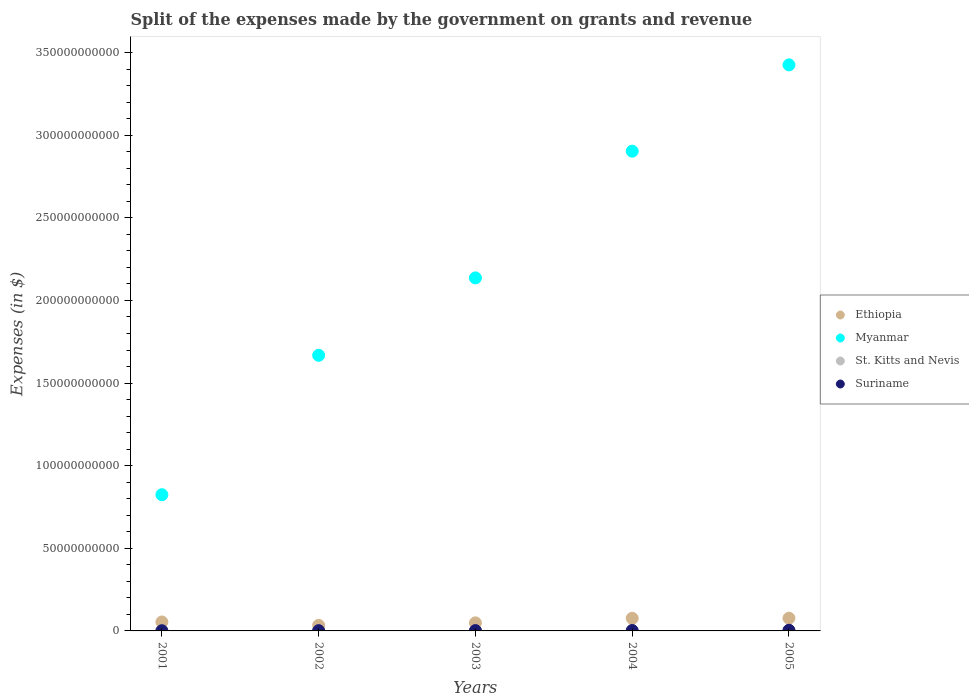How many different coloured dotlines are there?
Your response must be concise. 4. Is the number of dotlines equal to the number of legend labels?
Ensure brevity in your answer.  Yes. What is the expenses made by the government on grants and revenue in Ethiopia in 2005?
Keep it short and to the point. 7.71e+09. Across all years, what is the maximum expenses made by the government on grants and revenue in Myanmar?
Ensure brevity in your answer.  3.43e+11. Across all years, what is the minimum expenses made by the government on grants and revenue in Suriname?
Provide a short and direct response. 1.17e+08. In which year was the expenses made by the government on grants and revenue in Suriname maximum?
Offer a very short reply. 2005. In which year was the expenses made by the government on grants and revenue in Myanmar minimum?
Offer a terse response. 2001. What is the total expenses made by the government on grants and revenue in Suriname in the graph?
Your answer should be compact. 1.14e+09. What is the difference between the expenses made by the government on grants and revenue in Ethiopia in 2001 and that in 2002?
Keep it short and to the point. 2.05e+09. What is the difference between the expenses made by the government on grants and revenue in St. Kitts and Nevis in 2004 and the expenses made by the government on grants and revenue in Suriname in 2002?
Make the answer very short. -7.63e+07. What is the average expenses made by the government on grants and revenue in St. Kitts and Nevis per year?
Offer a very short reply. 1.03e+08. In the year 2005, what is the difference between the expenses made by the government on grants and revenue in St. Kitts and Nevis and expenses made by the government on grants and revenue in Ethiopia?
Offer a terse response. -7.59e+09. In how many years, is the expenses made by the government on grants and revenue in Myanmar greater than 70000000000 $?
Your response must be concise. 5. What is the ratio of the expenses made by the government on grants and revenue in Ethiopia in 2004 to that in 2005?
Give a very brief answer. 0.99. Is the difference between the expenses made by the government on grants and revenue in St. Kitts and Nevis in 2001 and 2005 greater than the difference between the expenses made by the government on grants and revenue in Ethiopia in 2001 and 2005?
Make the answer very short. Yes. What is the difference between the highest and the second highest expenses made by the government on grants and revenue in Suriname?
Ensure brevity in your answer.  1.41e+08. What is the difference between the highest and the lowest expenses made by the government on grants and revenue in Suriname?
Make the answer very short. 2.78e+08. In how many years, is the expenses made by the government on grants and revenue in Ethiopia greater than the average expenses made by the government on grants and revenue in Ethiopia taken over all years?
Give a very brief answer. 2. Is it the case that in every year, the sum of the expenses made by the government on grants and revenue in Suriname and expenses made by the government on grants and revenue in St. Kitts and Nevis  is greater than the sum of expenses made by the government on grants and revenue in Myanmar and expenses made by the government on grants and revenue in Ethiopia?
Your answer should be very brief. No. Is it the case that in every year, the sum of the expenses made by the government on grants and revenue in Suriname and expenses made by the government on grants and revenue in Ethiopia  is greater than the expenses made by the government on grants and revenue in St. Kitts and Nevis?
Your answer should be very brief. Yes. Is the expenses made by the government on grants and revenue in St. Kitts and Nevis strictly greater than the expenses made by the government on grants and revenue in Ethiopia over the years?
Offer a terse response. No. What is the difference between two consecutive major ticks on the Y-axis?
Ensure brevity in your answer.  5.00e+1. Does the graph contain any zero values?
Your answer should be very brief. No. Does the graph contain grids?
Your answer should be very brief. No. Where does the legend appear in the graph?
Provide a succinct answer. Center right. What is the title of the graph?
Your answer should be compact. Split of the expenses made by the government on grants and revenue. What is the label or title of the X-axis?
Provide a short and direct response. Years. What is the label or title of the Y-axis?
Give a very brief answer. Expenses (in $). What is the Expenses (in $) of Ethiopia in 2001?
Your answer should be compact. 5.41e+09. What is the Expenses (in $) of Myanmar in 2001?
Offer a very short reply. 8.24e+1. What is the Expenses (in $) of St. Kitts and Nevis in 2001?
Your answer should be compact. 9.49e+07. What is the Expenses (in $) of Suriname in 2001?
Make the answer very short. 1.17e+08. What is the Expenses (in $) of Ethiopia in 2002?
Offer a very short reply. 3.36e+09. What is the Expenses (in $) of Myanmar in 2002?
Keep it short and to the point. 1.67e+11. What is the Expenses (in $) in St. Kitts and Nevis in 2002?
Provide a short and direct response. 1.15e+08. What is the Expenses (in $) of Suriname in 2002?
Provide a short and direct response. 1.64e+08. What is the Expenses (in $) of Ethiopia in 2003?
Make the answer very short. 4.88e+09. What is the Expenses (in $) of Myanmar in 2003?
Provide a short and direct response. 2.14e+11. What is the Expenses (in $) in St. Kitts and Nevis in 2003?
Your answer should be compact. 9.36e+07. What is the Expenses (in $) of Suriname in 2003?
Provide a succinct answer. 2.09e+08. What is the Expenses (in $) in Ethiopia in 2004?
Your answer should be very brief. 7.63e+09. What is the Expenses (in $) in Myanmar in 2004?
Offer a very short reply. 2.90e+11. What is the Expenses (in $) in St. Kitts and Nevis in 2004?
Offer a very short reply. 8.76e+07. What is the Expenses (in $) of Suriname in 2004?
Provide a short and direct response. 2.53e+08. What is the Expenses (in $) of Ethiopia in 2005?
Make the answer very short. 7.71e+09. What is the Expenses (in $) in Myanmar in 2005?
Give a very brief answer. 3.43e+11. What is the Expenses (in $) in St. Kitts and Nevis in 2005?
Make the answer very short. 1.22e+08. What is the Expenses (in $) of Suriname in 2005?
Provide a short and direct response. 3.94e+08. Across all years, what is the maximum Expenses (in $) in Ethiopia?
Offer a very short reply. 7.71e+09. Across all years, what is the maximum Expenses (in $) of Myanmar?
Offer a terse response. 3.43e+11. Across all years, what is the maximum Expenses (in $) in St. Kitts and Nevis?
Offer a very short reply. 1.22e+08. Across all years, what is the maximum Expenses (in $) in Suriname?
Offer a very short reply. 3.94e+08. Across all years, what is the minimum Expenses (in $) in Ethiopia?
Your response must be concise. 3.36e+09. Across all years, what is the minimum Expenses (in $) of Myanmar?
Make the answer very short. 8.24e+1. Across all years, what is the minimum Expenses (in $) of St. Kitts and Nevis?
Your answer should be very brief. 8.76e+07. Across all years, what is the minimum Expenses (in $) in Suriname?
Provide a succinct answer. 1.17e+08. What is the total Expenses (in $) of Ethiopia in the graph?
Your response must be concise. 2.90e+1. What is the total Expenses (in $) in Myanmar in the graph?
Your response must be concise. 1.10e+12. What is the total Expenses (in $) of St. Kitts and Nevis in the graph?
Make the answer very short. 5.13e+08. What is the total Expenses (in $) of Suriname in the graph?
Your answer should be compact. 1.14e+09. What is the difference between the Expenses (in $) of Ethiopia in 2001 and that in 2002?
Provide a succinct answer. 2.05e+09. What is the difference between the Expenses (in $) of Myanmar in 2001 and that in 2002?
Offer a very short reply. -8.44e+1. What is the difference between the Expenses (in $) of St. Kitts and Nevis in 2001 and that in 2002?
Offer a terse response. -2.04e+07. What is the difference between the Expenses (in $) in Suriname in 2001 and that in 2002?
Provide a short and direct response. -4.73e+07. What is the difference between the Expenses (in $) of Ethiopia in 2001 and that in 2003?
Give a very brief answer. 5.34e+08. What is the difference between the Expenses (in $) of Myanmar in 2001 and that in 2003?
Your answer should be very brief. -1.31e+11. What is the difference between the Expenses (in $) in St. Kitts and Nevis in 2001 and that in 2003?
Provide a succinct answer. 1.30e+06. What is the difference between the Expenses (in $) in Suriname in 2001 and that in 2003?
Ensure brevity in your answer.  -9.21e+07. What is the difference between the Expenses (in $) of Ethiopia in 2001 and that in 2004?
Offer a terse response. -2.22e+09. What is the difference between the Expenses (in $) of Myanmar in 2001 and that in 2004?
Give a very brief answer. -2.08e+11. What is the difference between the Expenses (in $) of St. Kitts and Nevis in 2001 and that in 2004?
Your response must be concise. 7.30e+06. What is the difference between the Expenses (in $) of Suriname in 2001 and that in 2004?
Make the answer very short. -1.37e+08. What is the difference between the Expenses (in $) in Ethiopia in 2001 and that in 2005?
Offer a very short reply. -2.30e+09. What is the difference between the Expenses (in $) in Myanmar in 2001 and that in 2005?
Give a very brief answer. -2.60e+11. What is the difference between the Expenses (in $) of St. Kitts and Nevis in 2001 and that in 2005?
Your answer should be very brief. -2.69e+07. What is the difference between the Expenses (in $) in Suriname in 2001 and that in 2005?
Provide a succinct answer. -2.78e+08. What is the difference between the Expenses (in $) of Ethiopia in 2002 and that in 2003?
Offer a terse response. -1.51e+09. What is the difference between the Expenses (in $) of Myanmar in 2002 and that in 2003?
Your answer should be compact. -4.68e+1. What is the difference between the Expenses (in $) in St. Kitts and Nevis in 2002 and that in 2003?
Offer a very short reply. 2.17e+07. What is the difference between the Expenses (in $) in Suriname in 2002 and that in 2003?
Keep it short and to the point. -4.48e+07. What is the difference between the Expenses (in $) in Ethiopia in 2002 and that in 2004?
Offer a very short reply. -4.27e+09. What is the difference between the Expenses (in $) of Myanmar in 2002 and that in 2004?
Your response must be concise. -1.24e+11. What is the difference between the Expenses (in $) in St. Kitts and Nevis in 2002 and that in 2004?
Provide a short and direct response. 2.77e+07. What is the difference between the Expenses (in $) in Suriname in 2002 and that in 2004?
Provide a short and direct response. -8.93e+07. What is the difference between the Expenses (in $) in Ethiopia in 2002 and that in 2005?
Make the answer very short. -4.35e+09. What is the difference between the Expenses (in $) in Myanmar in 2002 and that in 2005?
Ensure brevity in your answer.  -1.76e+11. What is the difference between the Expenses (in $) in St. Kitts and Nevis in 2002 and that in 2005?
Offer a terse response. -6.50e+06. What is the difference between the Expenses (in $) in Suriname in 2002 and that in 2005?
Your answer should be very brief. -2.30e+08. What is the difference between the Expenses (in $) in Ethiopia in 2003 and that in 2004?
Your response must be concise. -2.76e+09. What is the difference between the Expenses (in $) of Myanmar in 2003 and that in 2004?
Provide a short and direct response. -7.67e+1. What is the difference between the Expenses (in $) of Suriname in 2003 and that in 2004?
Provide a short and direct response. -4.45e+07. What is the difference between the Expenses (in $) of Ethiopia in 2003 and that in 2005?
Give a very brief answer. -2.84e+09. What is the difference between the Expenses (in $) in Myanmar in 2003 and that in 2005?
Ensure brevity in your answer.  -1.29e+11. What is the difference between the Expenses (in $) of St. Kitts and Nevis in 2003 and that in 2005?
Your answer should be compact. -2.82e+07. What is the difference between the Expenses (in $) of Suriname in 2003 and that in 2005?
Provide a short and direct response. -1.86e+08. What is the difference between the Expenses (in $) in Ethiopia in 2004 and that in 2005?
Provide a short and direct response. -7.96e+07. What is the difference between the Expenses (in $) of Myanmar in 2004 and that in 2005?
Your response must be concise. -5.22e+1. What is the difference between the Expenses (in $) in St. Kitts and Nevis in 2004 and that in 2005?
Your response must be concise. -3.42e+07. What is the difference between the Expenses (in $) of Suriname in 2004 and that in 2005?
Make the answer very short. -1.41e+08. What is the difference between the Expenses (in $) in Ethiopia in 2001 and the Expenses (in $) in Myanmar in 2002?
Make the answer very short. -1.61e+11. What is the difference between the Expenses (in $) of Ethiopia in 2001 and the Expenses (in $) of St. Kitts and Nevis in 2002?
Give a very brief answer. 5.30e+09. What is the difference between the Expenses (in $) in Ethiopia in 2001 and the Expenses (in $) in Suriname in 2002?
Ensure brevity in your answer.  5.25e+09. What is the difference between the Expenses (in $) in Myanmar in 2001 and the Expenses (in $) in St. Kitts and Nevis in 2002?
Your answer should be very brief. 8.23e+1. What is the difference between the Expenses (in $) of Myanmar in 2001 and the Expenses (in $) of Suriname in 2002?
Offer a terse response. 8.23e+1. What is the difference between the Expenses (in $) in St. Kitts and Nevis in 2001 and the Expenses (in $) in Suriname in 2002?
Your response must be concise. -6.90e+07. What is the difference between the Expenses (in $) in Ethiopia in 2001 and the Expenses (in $) in Myanmar in 2003?
Keep it short and to the point. -2.08e+11. What is the difference between the Expenses (in $) in Ethiopia in 2001 and the Expenses (in $) in St. Kitts and Nevis in 2003?
Ensure brevity in your answer.  5.32e+09. What is the difference between the Expenses (in $) of Ethiopia in 2001 and the Expenses (in $) of Suriname in 2003?
Provide a succinct answer. 5.20e+09. What is the difference between the Expenses (in $) in Myanmar in 2001 and the Expenses (in $) in St. Kitts and Nevis in 2003?
Your answer should be compact. 8.23e+1. What is the difference between the Expenses (in $) of Myanmar in 2001 and the Expenses (in $) of Suriname in 2003?
Provide a succinct answer. 8.22e+1. What is the difference between the Expenses (in $) in St. Kitts and Nevis in 2001 and the Expenses (in $) in Suriname in 2003?
Ensure brevity in your answer.  -1.14e+08. What is the difference between the Expenses (in $) of Ethiopia in 2001 and the Expenses (in $) of Myanmar in 2004?
Provide a succinct answer. -2.85e+11. What is the difference between the Expenses (in $) of Ethiopia in 2001 and the Expenses (in $) of St. Kitts and Nevis in 2004?
Your response must be concise. 5.32e+09. What is the difference between the Expenses (in $) of Ethiopia in 2001 and the Expenses (in $) of Suriname in 2004?
Make the answer very short. 5.16e+09. What is the difference between the Expenses (in $) of Myanmar in 2001 and the Expenses (in $) of St. Kitts and Nevis in 2004?
Your answer should be very brief. 8.24e+1. What is the difference between the Expenses (in $) in Myanmar in 2001 and the Expenses (in $) in Suriname in 2004?
Your answer should be compact. 8.22e+1. What is the difference between the Expenses (in $) in St. Kitts and Nevis in 2001 and the Expenses (in $) in Suriname in 2004?
Give a very brief answer. -1.58e+08. What is the difference between the Expenses (in $) of Ethiopia in 2001 and the Expenses (in $) of Myanmar in 2005?
Give a very brief answer. -3.37e+11. What is the difference between the Expenses (in $) of Ethiopia in 2001 and the Expenses (in $) of St. Kitts and Nevis in 2005?
Keep it short and to the point. 5.29e+09. What is the difference between the Expenses (in $) in Ethiopia in 2001 and the Expenses (in $) in Suriname in 2005?
Your answer should be compact. 5.02e+09. What is the difference between the Expenses (in $) of Myanmar in 2001 and the Expenses (in $) of St. Kitts and Nevis in 2005?
Give a very brief answer. 8.23e+1. What is the difference between the Expenses (in $) in Myanmar in 2001 and the Expenses (in $) in Suriname in 2005?
Your answer should be compact. 8.20e+1. What is the difference between the Expenses (in $) in St. Kitts and Nevis in 2001 and the Expenses (in $) in Suriname in 2005?
Your answer should be compact. -2.99e+08. What is the difference between the Expenses (in $) in Ethiopia in 2002 and the Expenses (in $) in Myanmar in 2003?
Make the answer very short. -2.10e+11. What is the difference between the Expenses (in $) in Ethiopia in 2002 and the Expenses (in $) in St. Kitts and Nevis in 2003?
Provide a short and direct response. 3.27e+09. What is the difference between the Expenses (in $) of Ethiopia in 2002 and the Expenses (in $) of Suriname in 2003?
Your answer should be compact. 3.15e+09. What is the difference between the Expenses (in $) of Myanmar in 2002 and the Expenses (in $) of St. Kitts and Nevis in 2003?
Give a very brief answer. 1.67e+11. What is the difference between the Expenses (in $) of Myanmar in 2002 and the Expenses (in $) of Suriname in 2003?
Give a very brief answer. 1.67e+11. What is the difference between the Expenses (in $) of St. Kitts and Nevis in 2002 and the Expenses (in $) of Suriname in 2003?
Keep it short and to the point. -9.35e+07. What is the difference between the Expenses (in $) of Ethiopia in 2002 and the Expenses (in $) of Myanmar in 2004?
Your answer should be compact. -2.87e+11. What is the difference between the Expenses (in $) in Ethiopia in 2002 and the Expenses (in $) in St. Kitts and Nevis in 2004?
Offer a terse response. 3.27e+09. What is the difference between the Expenses (in $) in Ethiopia in 2002 and the Expenses (in $) in Suriname in 2004?
Your answer should be compact. 3.11e+09. What is the difference between the Expenses (in $) in Myanmar in 2002 and the Expenses (in $) in St. Kitts and Nevis in 2004?
Ensure brevity in your answer.  1.67e+11. What is the difference between the Expenses (in $) of Myanmar in 2002 and the Expenses (in $) of Suriname in 2004?
Provide a succinct answer. 1.67e+11. What is the difference between the Expenses (in $) of St. Kitts and Nevis in 2002 and the Expenses (in $) of Suriname in 2004?
Keep it short and to the point. -1.38e+08. What is the difference between the Expenses (in $) of Ethiopia in 2002 and the Expenses (in $) of Myanmar in 2005?
Your answer should be very brief. -3.39e+11. What is the difference between the Expenses (in $) in Ethiopia in 2002 and the Expenses (in $) in St. Kitts and Nevis in 2005?
Give a very brief answer. 3.24e+09. What is the difference between the Expenses (in $) in Ethiopia in 2002 and the Expenses (in $) in Suriname in 2005?
Your response must be concise. 2.97e+09. What is the difference between the Expenses (in $) in Myanmar in 2002 and the Expenses (in $) in St. Kitts and Nevis in 2005?
Your answer should be very brief. 1.67e+11. What is the difference between the Expenses (in $) in Myanmar in 2002 and the Expenses (in $) in Suriname in 2005?
Offer a very short reply. 1.66e+11. What is the difference between the Expenses (in $) in St. Kitts and Nevis in 2002 and the Expenses (in $) in Suriname in 2005?
Your response must be concise. -2.79e+08. What is the difference between the Expenses (in $) of Ethiopia in 2003 and the Expenses (in $) of Myanmar in 2004?
Make the answer very short. -2.85e+11. What is the difference between the Expenses (in $) in Ethiopia in 2003 and the Expenses (in $) in St. Kitts and Nevis in 2004?
Keep it short and to the point. 4.79e+09. What is the difference between the Expenses (in $) in Ethiopia in 2003 and the Expenses (in $) in Suriname in 2004?
Keep it short and to the point. 4.62e+09. What is the difference between the Expenses (in $) in Myanmar in 2003 and the Expenses (in $) in St. Kitts and Nevis in 2004?
Offer a terse response. 2.14e+11. What is the difference between the Expenses (in $) in Myanmar in 2003 and the Expenses (in $) in Suriname in 2004?
Make the answer very short. 2.13e+11. What is the difference between the Expenses (in $) in St. Kitts and Nevis in 2003 and the Expenses (in $) in Suriname in 2004?
Keep it short and to the point. -1.60e+08. What is the difference between the Expenses (in $) in Ethiopia in 2003 and the Expenses (in $) in Myanmar in 2005?
Provide a short and direct response. -3.38e+11. What is the difference between the Expenses (in $) in Ethiopia in 2003 and the Expenses (in $) in St. Kitts and Nevis in 2005?
Ensure brevity in your answer.  4.75e+09. What is the difference between the Expenses (in $) of Ethiopia in 2003 and the Expenses (in $) of Suriname in 2005?
Your answer should be very brief. 4.48e+09. What is the difference between the Expenses (in $) in Myanmar in 2003 and the Expenses (in $) in St. Kitts and Nevis in 2005?
Offer a terse response. 2.14e+11. What is the difference between the Expenses (in $) of Myanmar in 2003 and the Expenses (in $) of Suriname in 2005?
Your response must be concise. 2.13e+11. What is the difference between the Expenses (in $) of St. Kitts and Nevis in 2003 and the Expenses (in $) of Suriname in 2005?
Make the answer very short. -3.01e+08. What is the difference between the Expenses (in $) of Ethiopia in 2004 and the Expenses (in $) of Myanmar in 2005?
Offer a very short reply. -3.35e+11. What is the difference between the Expenses (in $) in Ethiopia in 2004 and the Expenses (in $) in St. Kitts and Nevis in 2005?
Your response must be concise. 7.51e+09. What is the difference between the Expenses (in $) of Ethiopia in 2004 and the Expenses (in $) of Suriname in 2005?
Make the answer very short. 7.24e+09. What is the difference between the Expenses (in $) in Myanmar in 2004 and the Expenses (in $) in St. Kitts and Nevis in 2005?
Your answer should be very brief. 2.90e+11. What is the difference between the Expenses (in $) in Myanmar in 2004 and the Expenses (in $) in Suriname in 2005?
Give a very brief answer. 2.90e+11. What is the difference between the Expenses (in $) of St. Kitts and Nevis in 2004 and the Expenses (in $) of Suriname in 2005?
Your answer should be very brief. -3.07e+08. What is the average Expenses (in $) of Ethiopia per year?
Keep it short and to the point. 5.80e+09. What is the average Expenses (in $) of Myanmar per year?
Provide a succinct answer. 2.19e+11. What is the average Expenses (in $) in St. Kitts and Nevis per year?
Give a very brief answer. 1.03e+08. What is the average Expenses (in $) of Suriname per year?
Offer a terse response. 2.27e+08. In the year 2001, what is the difference between the Expenses (in $) of Ethiopia and Expenses (in $) of Myanmar?
Provide a succinct answer. -7.70e+1. In the year 2001, what is the difference between the Expenses (in $) in Ethiopia and Expenses (in $) in St. Kitts and Nevis?
Your response must be concise. 5.32e+09. In the year 2001, what is the difference between the Expenses (in $) in Ethiopia and Expenses (in $) in Suriname?
Your answer should be very brief. 5.29e+09. In the year 2001, what is the difference between the Expenses (in $) in Myanmar and Expenses (in $) in St. Kitts and Nevis?
Ensure brevity in your answer.  8.23e+1. In the year 2001, what is the difference between the Expenses (in $) of Myanmar and Expenses (in $) of Suriname?
Your answer should be compact. 8.23e+1. In the year 2001, what is the difference between the Expenses (in $) in St. Kitts and Nevis and Expenses (in $) in Suriname?
Offer a terse response. -2.18e+07. In the year 2002, what is the difference between the Expenses (in $) of Ethiopia and Expenses (in $) of Myanmar?
Offer a very short reply. -1.63e+11. In the year 2002, what is the difference between the Expenses (in $) in Ethiopia and Expenses (in $) in St. Kitts and Nevis?
Keep it short and to the point. 3.25e+09. In the year 2002, what is the difference between the Expenses (in $) of Ethiopia and Expenses (in $) of Suriname?
Give a very brief answer. 3.20e+09. In the year 2002, what is the difference between the Expenses (in $) in Myanmar and Expenses (in $) in St. Kitts and Nevis?
Make the answer very short. 1.67e+11. In the year 2002, what is the difference between the Expenses (in $) in Myanmar and Expenses (in $) in Suriname?
Your answer should be very brief. 1.67e+11. In the year 2002, what is the difference between the Expenses (in $) in St. Kitts and Nevis and Expenses (in $) in Suriname?
Provide a succinct answer. -4.86e+07. In the year 2003, what is the difference between the Expenses (in $) in Ethiopia and Expenses (in $) in Myanmar?
Provide a short and direct response. -2.09e+11. In the year 2003, what is the difference between the Expenses (in $) of Ethiopia and Expenses (in $) of St. Kitts and Nevis?
Offer a terse response. 4.78e+09. In the year 2003, what is the difference between the Expenses (in $) in Ethiopia and Expenses (in $) in Suriname?
Keep it short and to the point. 4.67e+09. In the year 2003, what is the difference between the Expenses (in $) in Myanmar and Expenses (in $) in St. Kitts and Nevis?
Your response must be concise. 2.14e+11. In the year 2003, what is the difference between the Expenses (in $) of Myanmar and Expenses (in $) of Suriname?
Your answer should be compact. 2.13e+11. In the year 2003, what is the difference between the Expenses (in $) of St. Kitts and Nevis and Expenses (in $) of Suriname?
Provide a short and direct response. -1.15e+08. In the year 2004, what is the difference between the Expenses (in $) of Ethiopia and Expenses (in $) of Myanmar?
Your answer should be very brief. -2.83e+11. In the year 2004, what is the difference between the Expenses (in $) in Ethiopia and Expenses (in $) in St. Kitts and Nevis?
Ensure brevity in your answer.  7.55e+09. In the year 2004, what is the difference between the Expenses (in $) of Ethiopia and Expenses (in $) of Suriname?
Offer a very short reply. 7.38e+09. In the year 2004, what is the difference between the Expenses (in $) in Myanmar and Expenses (in $) in St. Kitts and Nevis?
Provide a succinct answer. 2.90e+11. In the year 2004, what is the difference between the Expenses (in $) of Myanmar and Expenses (in $) of Suriname?
Your answer should be compact. 2.90e+11. In the year 2004, what is the difference between the Expenses (in $) of St. Kitts and Nevis and Expenses (in $) of Suriname?
Provide a succinct answer. -1.66e+08. In the year 2005, what is the difference between the Expenses (in $) of Ethiopia and Expenses (in $) of Myanmar?
Keep it short and to the point. -3.35e+11. In the year 2005, what is the difference between the Expenses (in $) in Ethiopia and Expenses (in $) in St. Kitts and Nevis?
Your response must be concise. 7.59e+09. In the year 2005, what is the difference between the Expenses (in $) in Ethiopia and Expenses (in $) in Suriname?
Your response must be concise. 7.32e+09. In the year 2005, what is the difference between the Expenses (in $) of Myanmar and Expenses (in $) of St. Kitts and Nevis?
Offer a very short reply. 3.42e+11. In the year 2005, what is the difference between the Expenses (in $) in Myanmar and Expenses (in $) in Suriname?
Provide a succinct answer. 3.42e+11. In the year 2005, what is the difference between the Expenses (in $) in St. Kitts and Nevis and Expenses (in $) in Suriname?
Ensure brevity in your answer.  -2.73e+08. What is the ratio of the Expenses (in $) of Ethiopia in 2001 to that in 2002?
Your answer should be very brief. 1.61. What is the ratio of the Expenses (in $) in Myanmar in 2001 to that in 2002?
Your answer should be very brief. 0.49. What is the ratio of the Expenses (in $) in St. Kitts and Nevis in 2001 to that in 2002?
Offer a terse response. 0.82. What is the ratio of the Expenses (in $) in Suriname in 2001 to that in 2002?
Ensure brevity in your answer.  0.71. What is the ratio of the Expenses (in $) of Ethiopia in 2001 to that in 2003?
Offer a very short reply. 1.11. What is the ratio of the Expenses (in $) of Myanmar in 2001 to that in 2003?
Provide a succinct answer. 0.39. What is the ratio of the Expenses (in $) of St. Kitts and Nevis in 2001 to that in 2003?
Ensure brevity in your answer.  1.01. What is the ratio of the Expenses (in $) in Suriname in 2001 to that in 2003?
Keep it short and to the point. 0.56. What is the ratio of the Expenses (in $) in Ethiopia in 2001 to that in 2004?
Provide a short and direct response. 0.71. What is the ratio of the Expenses (in $) in Myanmar in 2001 to that in 2004?
Keep it short and to the point. 0.28. What is the ratio of the Expenses (in $) of Suriname in 2001 to that in 2004?
Provide a short and direct response. 0.46. What is the ratio of the Expenses (in $) in Ethiopia in 2001 to that in 2005?
Offer a very short reply. 0.7. What is the ratio of the Expenses (in $) of Myanmar in 2001 to that in 2005?
Make the answer very short. 0.24. What is the ratio of the Expenses (in $) in St. Kitts and Nevis in 2001 to that in 2005?
Ensure brevity in your answer.  0.78. What is the ratio of the Expenses (in $) of Suriname in 2001 to that in 2005?
Make the answer very short. 0.3. What is the ratio of the Expenses (in $) of Ethiopia in 2002 to that in 2003?
Provide a short and direct response. 0.69. What is the ratio of the Expenses (in $) of Myanmar in 2002 to that in 2003?
Your response must be concise. 0.78. What is the ratio of the Expenses (in $) in St. Kitts and Nevis in 2002 to that in 2003?
Make the answer very short. 1.23. What is the ratio of the Expenses (in $) in Suriname in 2002 to that in 2003?
Ensure brevity in your answer.  0.79. What is the ratio of the Expenses (in $) of Ethiopia in 2002 to that in 2004?
Give a very brief answer. 0.44. What is the ratio of the Expenses (in $) of Myanmar in 2002 to that in 2004?
Offer a very short reply. 0.57. What is the ratio of the Expenses (in $) in St. Kitts and Nevis in 2002 to that in 2004?
Your answer should be very brief. 1.32. What is the ratio of the Expenses (in $) in Suriname in 2002 to that in 2004?
Keep it short and to the point. 0.65. What is the ratio of the Expenses (in $) in Ethiopia in 2002 to that in 2005?
Provide a succinct answer. 0.44. What is the ratio of the Expenses (in $) in Myanmar in 2002 to that in 2005?
Give a very brief answer. 0.49. What is the ratio of the Expenses (in $) in St. Kitts and Nevis in 2002 to that in 2005?
Your answer should be compact. 0.95. What is the ratio of the Expenses (in $) in Suriname in 2002 to that in 2005?
Ensure brevity in your answer.  0.42. What is the ratio of the Expenses (in $) of Ethiopia in 2003 to that in 2004?
Keep it short and to the point. 0.64. What is the ratio of the Expenses (in $) in Myanmar in 2003 to that in 2004?
Provide a succinct answer. 0.74. What is the ratio of the Expenses (in $) of St. Kitts and Nevis in 2003 to that in 2004?
Offer a very short reply. 1.07. What is the ratio of the Expenses (in $) in Suriname in 2003 to that in 2004?
Ensure brevity in your answer.  0.82. What is the ratio of the Expenses (in $) in Ethiopia in 2003 to that in 2005?
Your answer should be compact. 0.63. What is the ratio of the Expenses (in $) of Myanmar in 2003 to that in 2005?
Give a very brief answer. 0.62. What is the ratio of the Expenses (in $) in St. Kitts and Nevis in 2003 to that in 2005?
Offer a terse response. 0.77. What is the ratio of the Expenses (in $) in Suriname in 2003 to that in 2005?
Give a very brief answer. 0.53. What is the ratio of the Expenses (in $) of Myanmar in 2004 to that in 2005?
Offer a terse response. 0.85. What is the ratio of the Expenses (in $) of St. Kitts and Nevis in 2004 to that in 2005?
Your answer should be very brief. 0.72. What is the ratio of the Expenses (in $) in Suriname in 2004 to that in 2005?
Make the answer very short. 0.64. What is the difference between the highest and the second highest Expenses (in $) in Ethiopia?
Make the answer very short. 7.96e+07. What is the difference between the highest and the second highest Expenses (in $) of Myanmar?
Provide a short and direct response. 5.22e+1. What is the difference between the highest and the second highest Expenses (in $) of St. Kitts and Nevis?
Ensure brevity in your answer.  6.50e+06. What is the difference between the highest and the second highest Expenses (in $) of Suriname?
Ensure brevity in your answer.  1.41e+08. What is the difference between the highest and the lowest Expenses (in $) of Ethiopia?
Your answer should be very brief. 4.35e+09. What is the difference between the highest and the lowest Expenses (in $) in Myanmar?
Your answer should be compact. 2.60e+11. What is the difference between the highest and the lowest Expenses (in $) of St. Kitts and Nevis?
Your response must be concise. 3.42e+07. What is the difference between the highest and the lowest Expenses (in $) in Suriname?
Your response must be concise. 2.78e+08. 